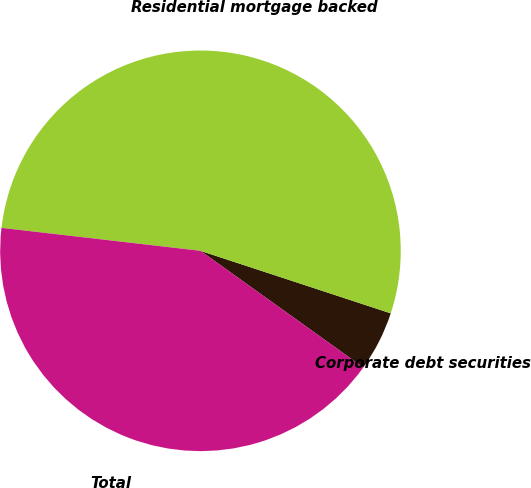<chart> <loc_0><loc_0><loc_500><loc_500><pie_chart><fcel>Corporate debt securities<fcel>Residential mortgage backed<fcel>Total<nl><fcel>4.84%<fcel>53.23%<fcel>41.94%<nl></chart> 